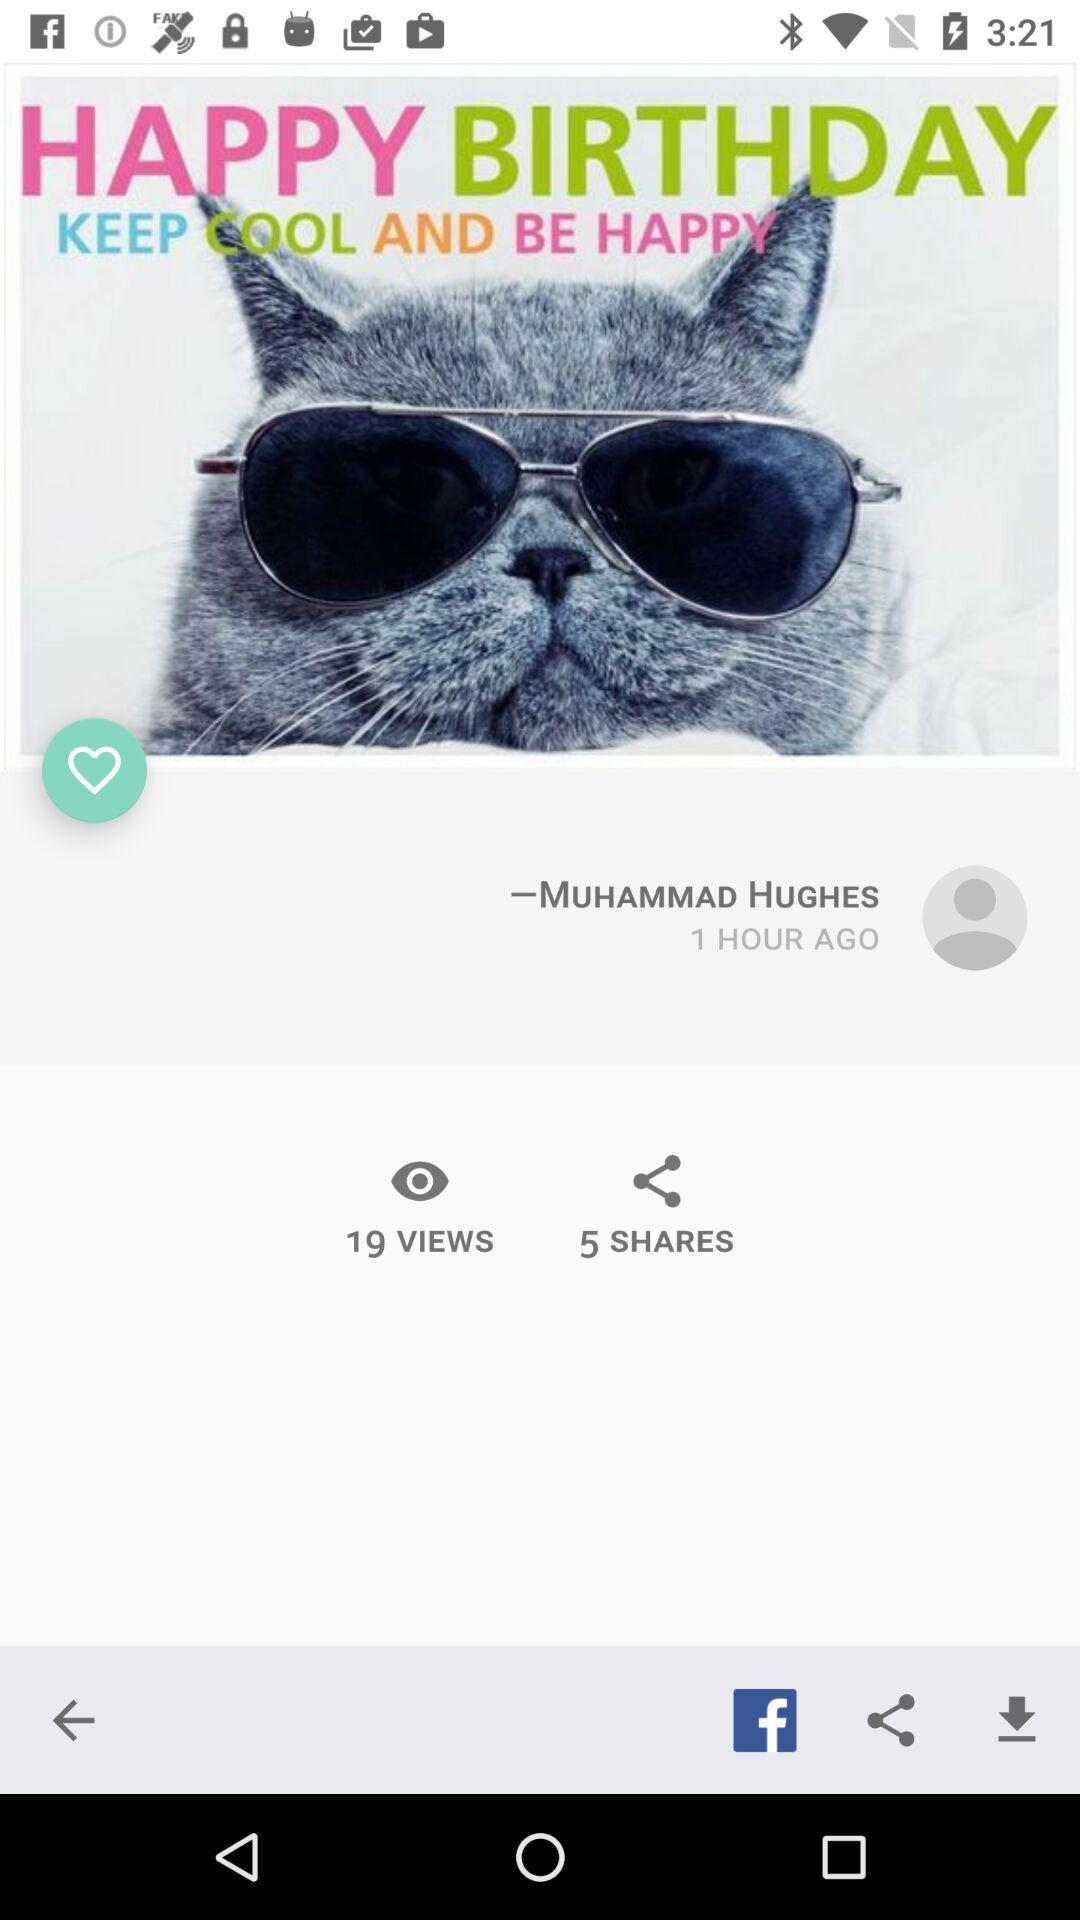How many views are there? There are 19 views. 